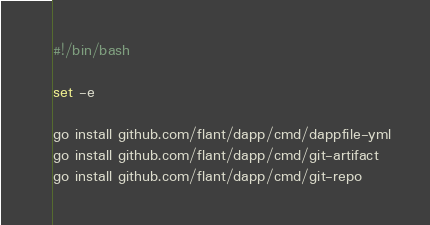Convert code to text. <code><loc_0><loc_0><loc_500><loc_500><_Bash_>#!/bin/bash

set -e

go install github.com/flant/dapp/cmd/dappfile-yml
go install github.com/flant/dapp/cmd/git-artifact
go install github.com/flant/dapp/cmd/git-repo</code> 